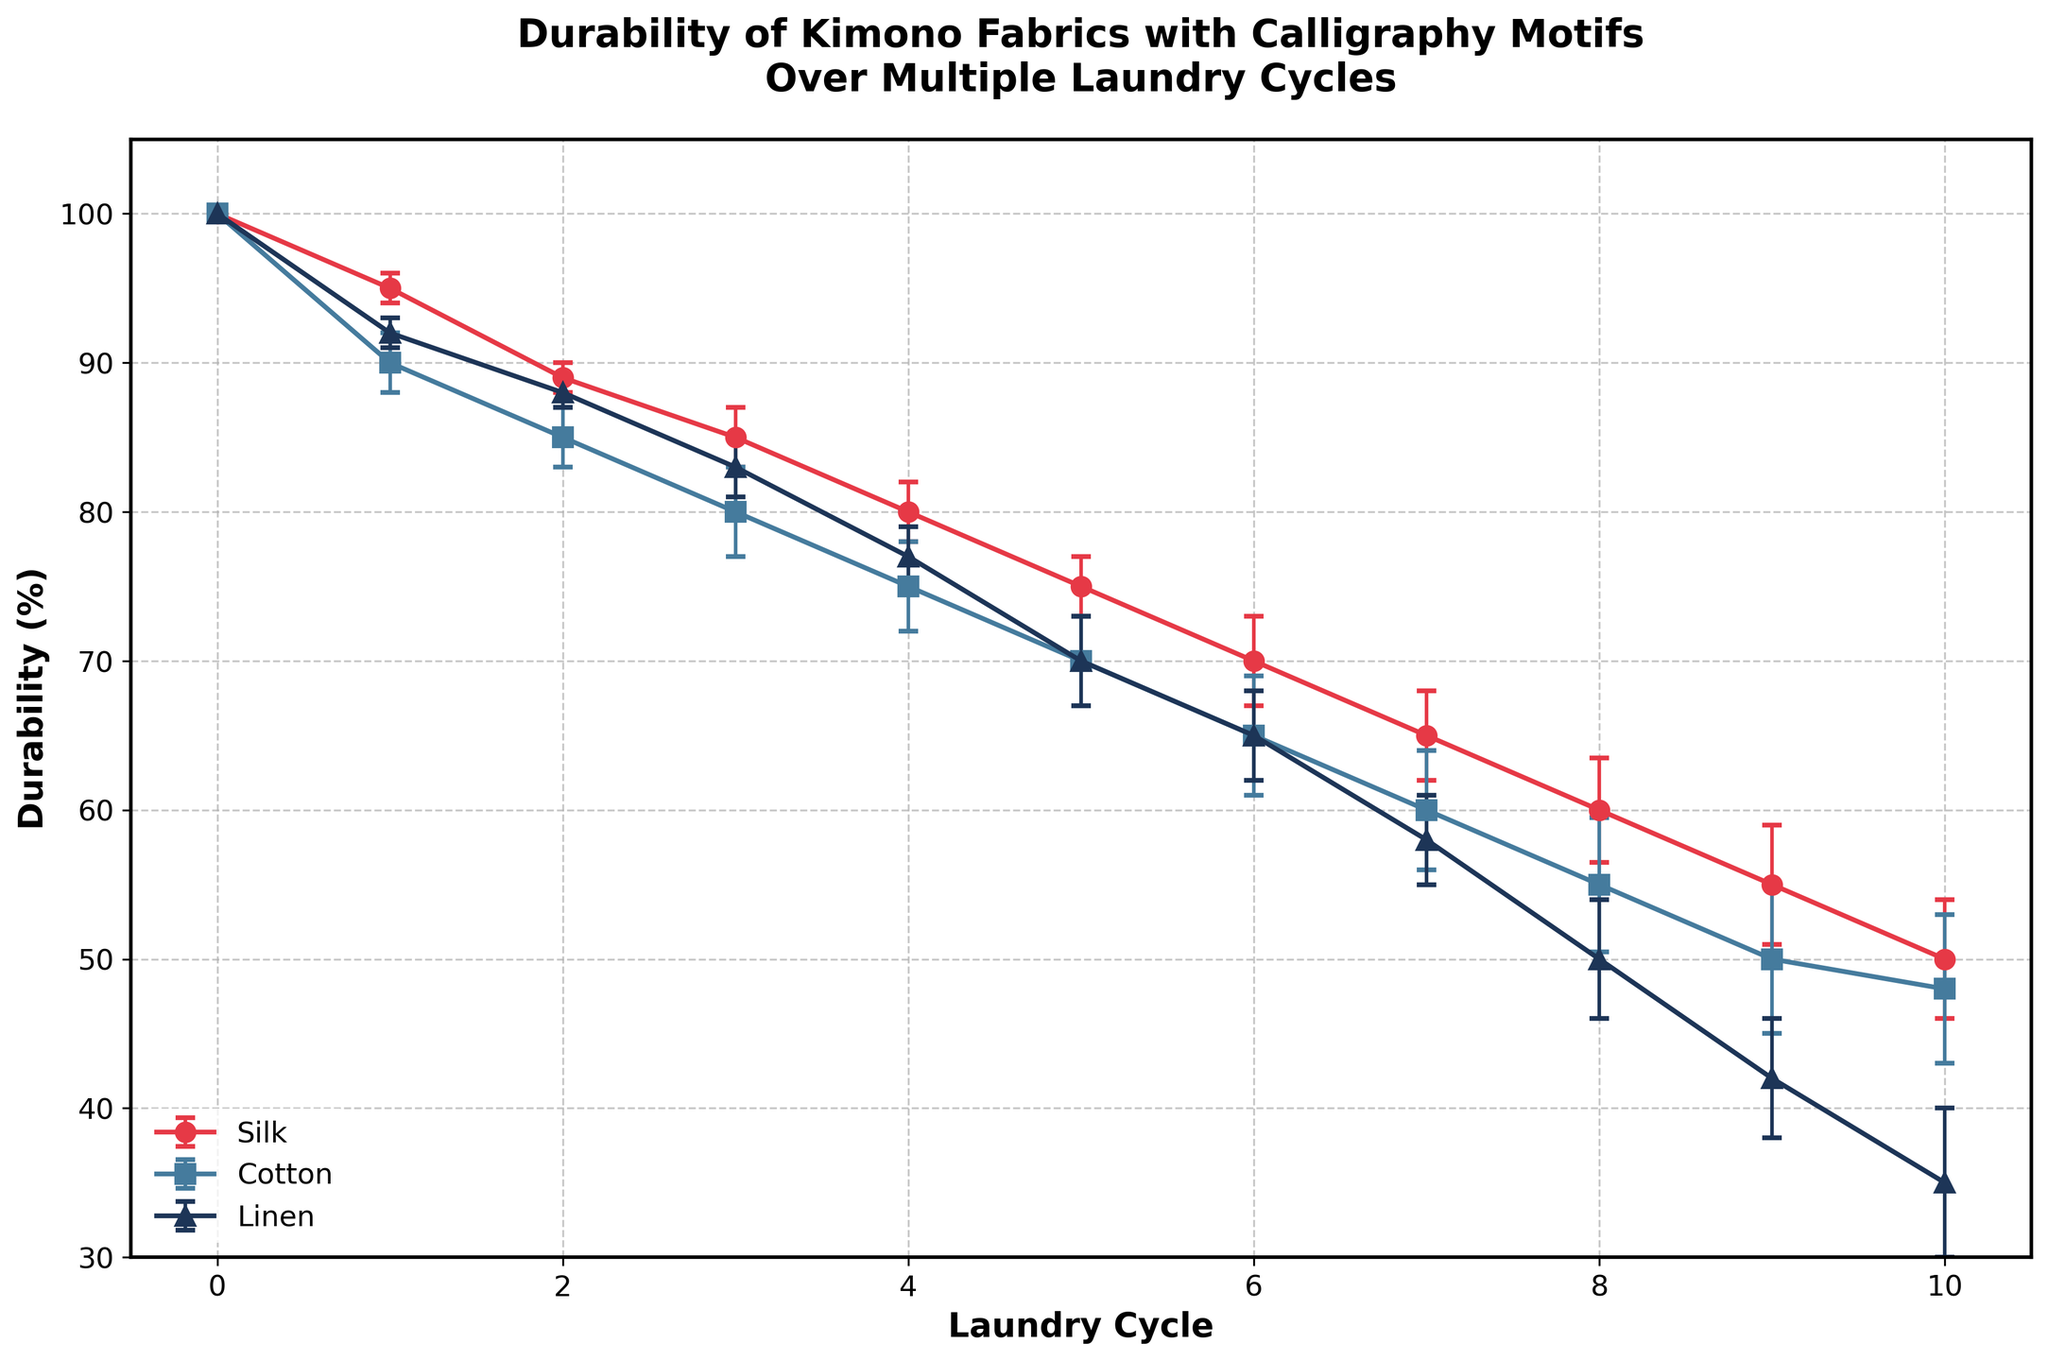What is the title of the plot? The title of the plot is typically found at the top of the figure in large and bold font, summarizing the content of the plot.
Answer: Durability of Kimono Fabrics with Calligraphy Motifs Over Multiple Laundry Cycles How many different types of kimono fabrics are analyzed in this plot? The different types of kimono fabrics are usually indicated by different labels in the legend, which show the distinct lines on the plot.
Answer: Three (Silk, Cotton, Linen) What are the color codes used for each fabric? The colors can be identified by referring to the lines and their corresponding legend entries. The legend matches each fabric type to its line's color.
Answer: Red for Silk, Blue for Cotton, Dark Blue for Linen How does the durability of Cotton change after 5 laundry cycles? The durability change can be tracked by following the Cotton line and reading the mean durability value at the 5th cycle and comparing it to the 0th cycle.
Answer: Decreases from 100% to 70% What is the difference in mean durability between Silk and Linen after 8 laundry cycles? To find this, locate the mean durability values for Silk and Linen at the 8th cycle. Subtract the mean value of Linen from that of Silk.
Answer: 60% - 50% = 10% Which fabric shows the highest variance in durability over 10 laundry cycles? Compare the error bars (standard error) across cycles for each fabric. The fabric with the largest average error bars has the highest variance.
Answer: Cotton What is the trend in the durability of Linen from the start until the 10th laundry cycle? Observe the line for Linen from cycle 0 to cycle 10, noting changes in the mean durability values to identify the overall trend.
Answer: Decreasing At which laundry cycle does Silk’s durability first drop to 85%? Find the point on the Silk line where the mean durability first reaches 85%, which is indicated by the data points and their values.
Answer: 3rd cycle On average, how much durability does Cotton lose after each laundry cycle? Determine the total loss in durability for Cotton from cycle 0 to cycle 10, and then divide by the number of cycles (10).
Answer: (100% - 48%) / 10 = 5.2% Which fabric retains the highest durability after 10 cycles and by how much greater is it compared to the least durable fabric at the same point? Identify the durability values for each fabric at the 10th cycle and compare them. Subtract the smallest value from the largest one.
Answer: Silk retains 50%, Linen 35%. The difference is 15% 